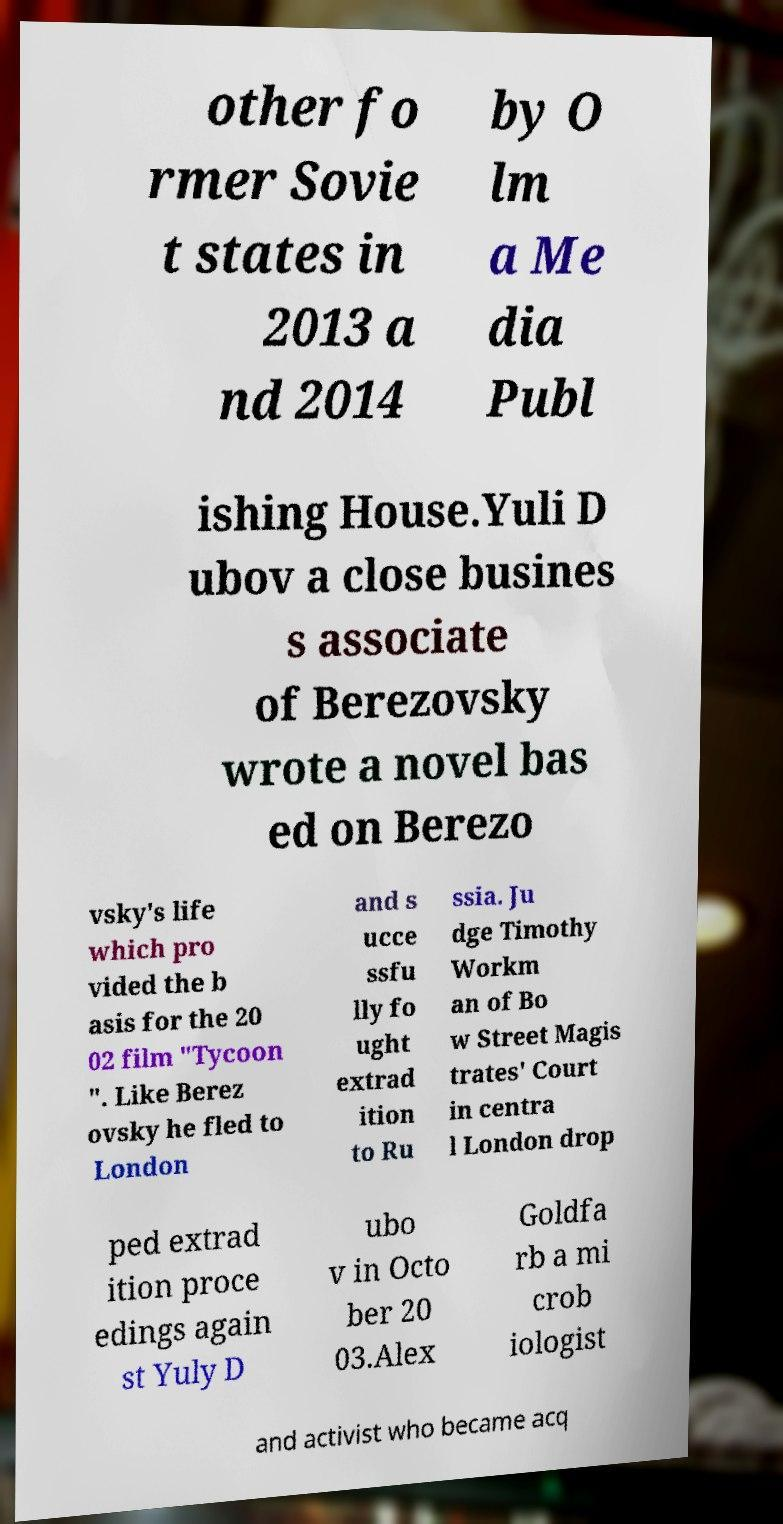Could you extract and type out the text from this image? other fo rmer Sovie t states in 2013 a nd 2014 by O lm a Me dia Publ ishing House.Yuli D ubov a close busines s associate of Berezovsky wrote a novel bas ed on Berezo vsky's life which pro vided the b asis for the 20 02 film "Tycoon ". Like Berez ovsky he fled to London and s ucce ssfu lly fo ught extrad ition to Ru ssia. Ju dge Timothy Workm an of Bo w Street Magis trates' Court in centra l London drop ped extrad ition proce edings again st Yuly D ubo v in Octo ber 20 03.Alex Goldfa rb a mi crob iologist and activist who became acq 